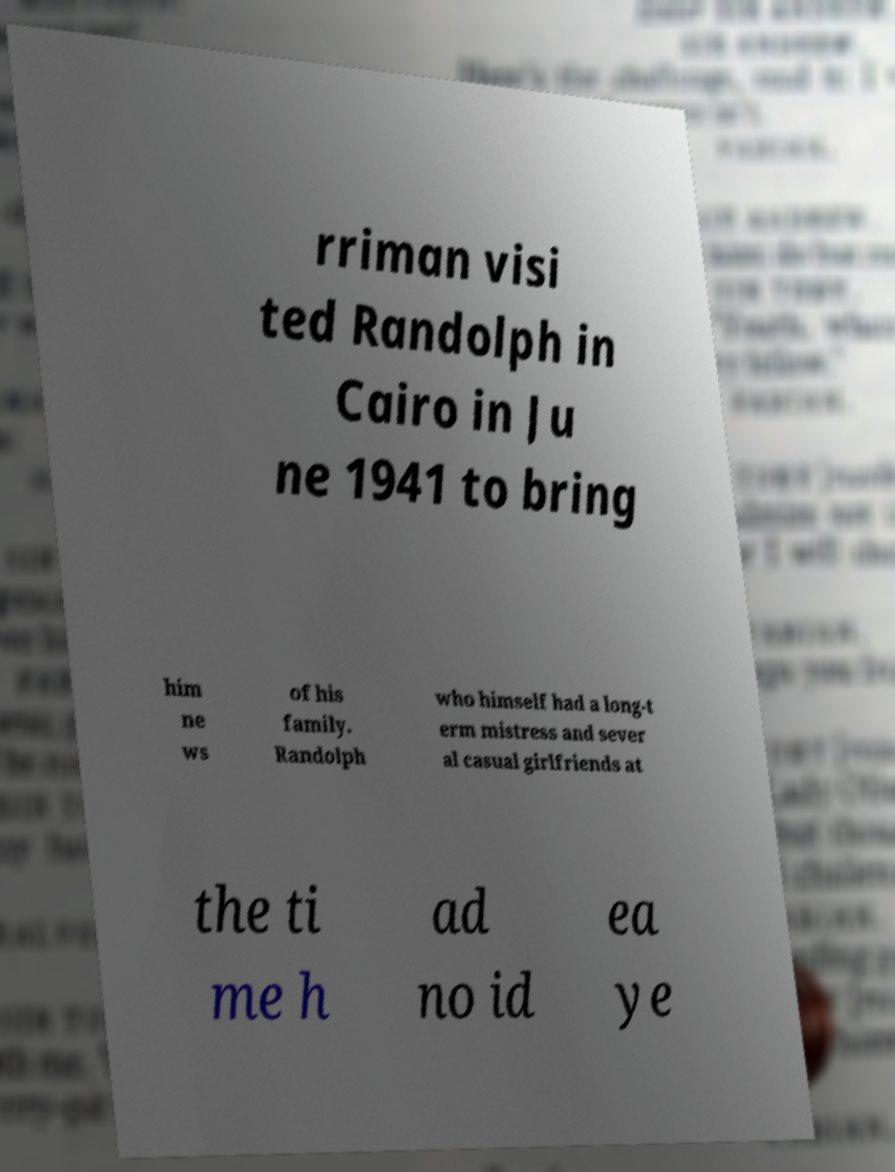There's text embedded in this image that I need extracted. Can you transcribe it verbatim? rriman visi ted Randolph in Cairo in Ju ne 1941 to bring him ne ws of his family. Randolph who himself had a long-t erm mistress and sever al casual girlfriends at the ti me h ad no id ea ye 